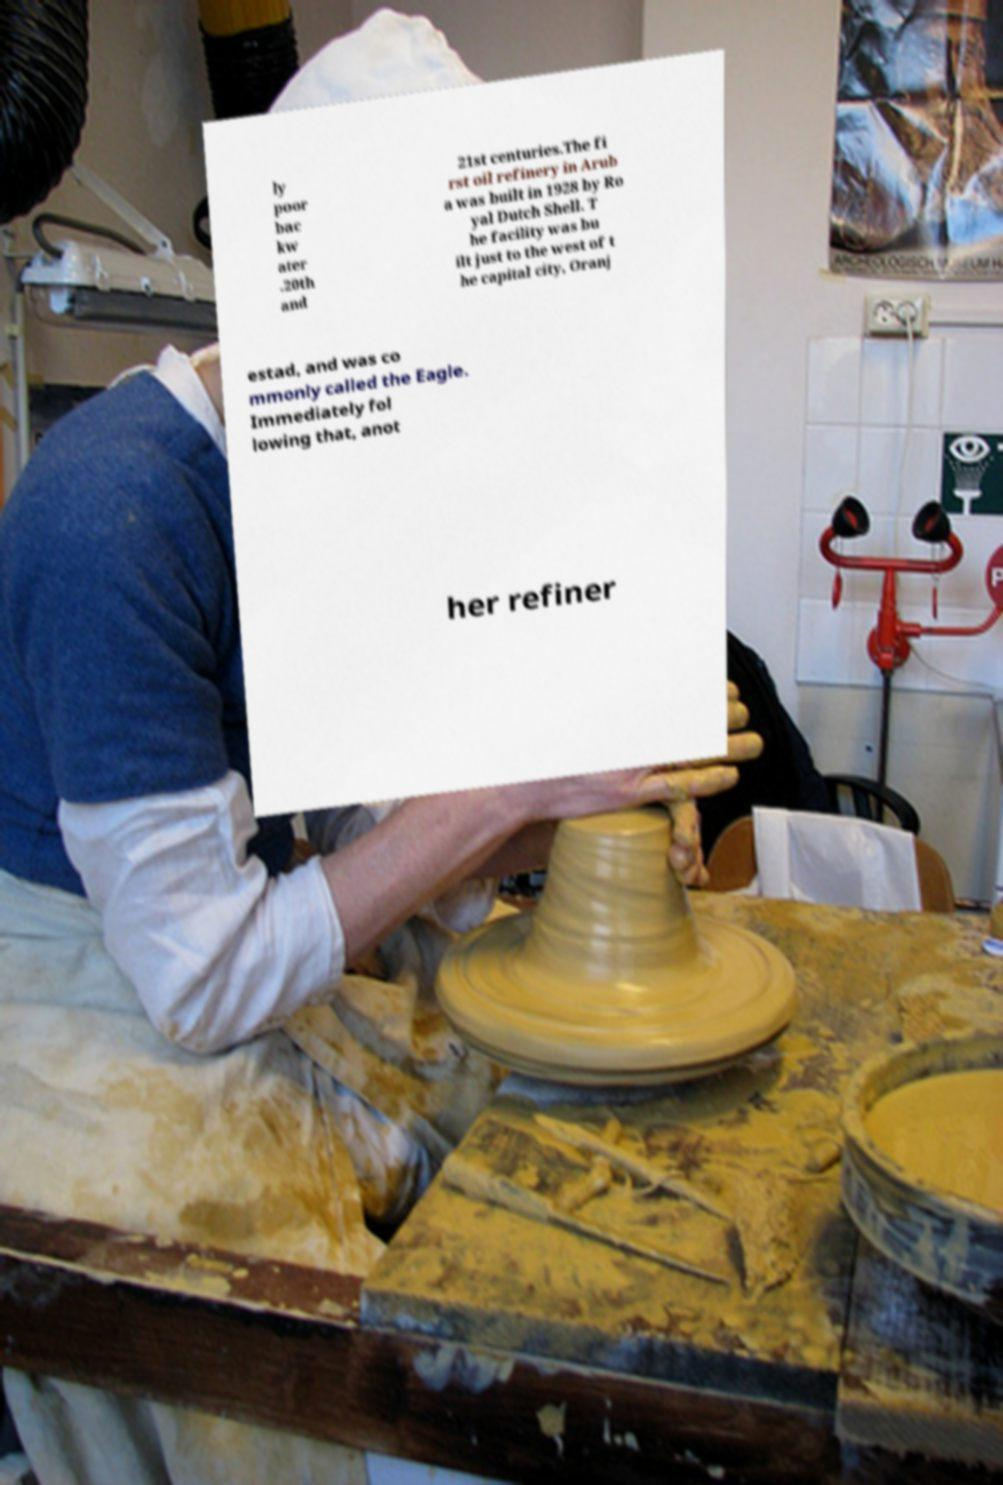There's text embedded in this image that I need extracted. Can you transcribe it verbatim? ly poor bac kw ater .20th and 21st centuries.The fi rst oil refinery in Arub a was built in 1928 by Ro yal Dutch Shell. T he facility was bu ilt just to the west of t he capital city, Oranj estad, and was co mmonly called the Eagle. Immediately fol lowing that, anot her refiner 